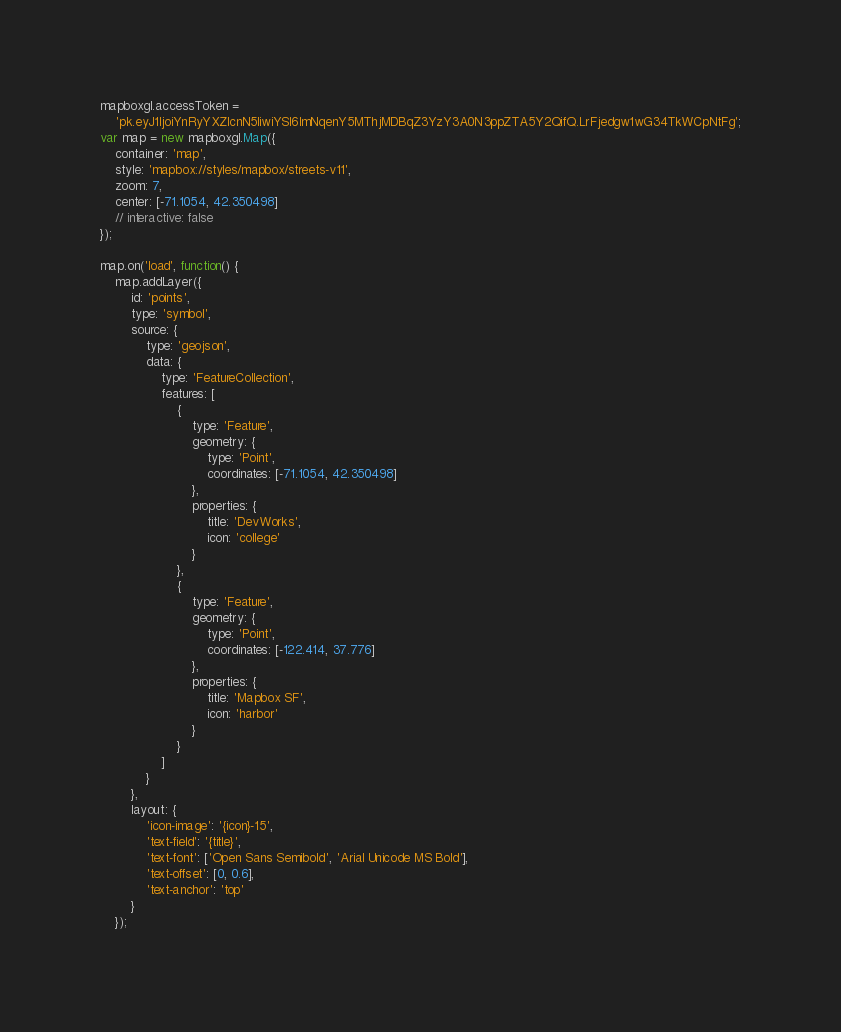<code> <loc_0><loc_0><loc_500><loc_500><_JavaScript_>mapboxgl.accessToken =
	'pk.eyJ1IjoiYnRyYXZlcnN5IiwiYSI6ImNqenY5MThjMDBqZ3YzY3A0N3ppZTA5Y2QifQ.LrFjedgw1wG34TkWCpNtFg';
var map = new mapboxgl.Map({
	container: 'map',
	style: 'mapbox://styles/mapbox/streets-v11',
	zoom: 7,
	center: [-71.1054, 42.350498]
	// interactive: false
});

map.on('load', function() {
	map.addLayer({
		id: 'points',
		type: 'symbol',
		source: {
			type: 'geojson',
			data: {
				type: 'FeatureCollection',
				features: [
					{
						type: 'Feature',
						geometry: {
							type: 'Point',
							coordinates: [-71.1054, 42.350498]
						},
						properties: {
							title: 'DevWorks',
							icon: 'college'
						}
					},
					{
						type: 'Feature',
						geometry: {
							type: 'Point',
							coordinates: [-122.414, 37.776]
						},
						properties: {
							title: 'Mapbox SF',
							icon: 'harbor'
						}
					}
				]
			}
		},
		layout: {
			'icon-image': '{icon}-15',
			'text-field': '{title}',
			'text-font': ['Open Sans Semibold', 'Arial Unicode MS Bold'],
			'text-offset': [0, 0.6],
			'text-anchor': 'top'
		}
	});</code> 